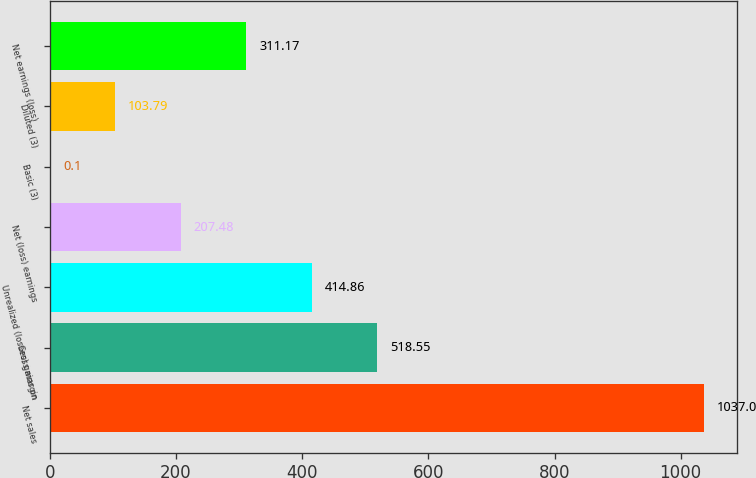Convert chart. <chart><loc_0><loc_0><loc_500><loc_500><bar_chart><fcel>Net sales<fcel>Gross margin<fcel>Unrealized (losses) gains on<fcel>Net (loss) earnings<fcel>Basic (3)<fcel>Diluted (3)<fcel>Net earnings (loss)<nl><fcel>1037<fcel>518.55<fcel>414.86<fcel>207.48<fcel>0.1<fcel>103.79<fcel>311.17<nl></chart> 